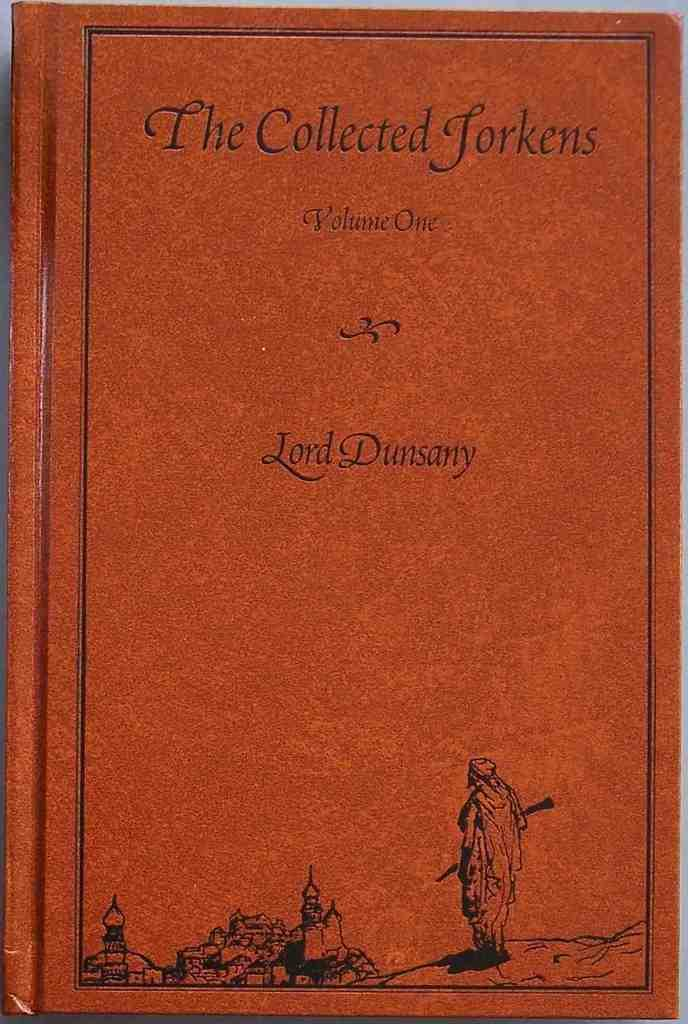<image>
Share a concise interpretation of the image provided. The book The Collected Torkens Volume one has a castle on the bottom of the cover. 